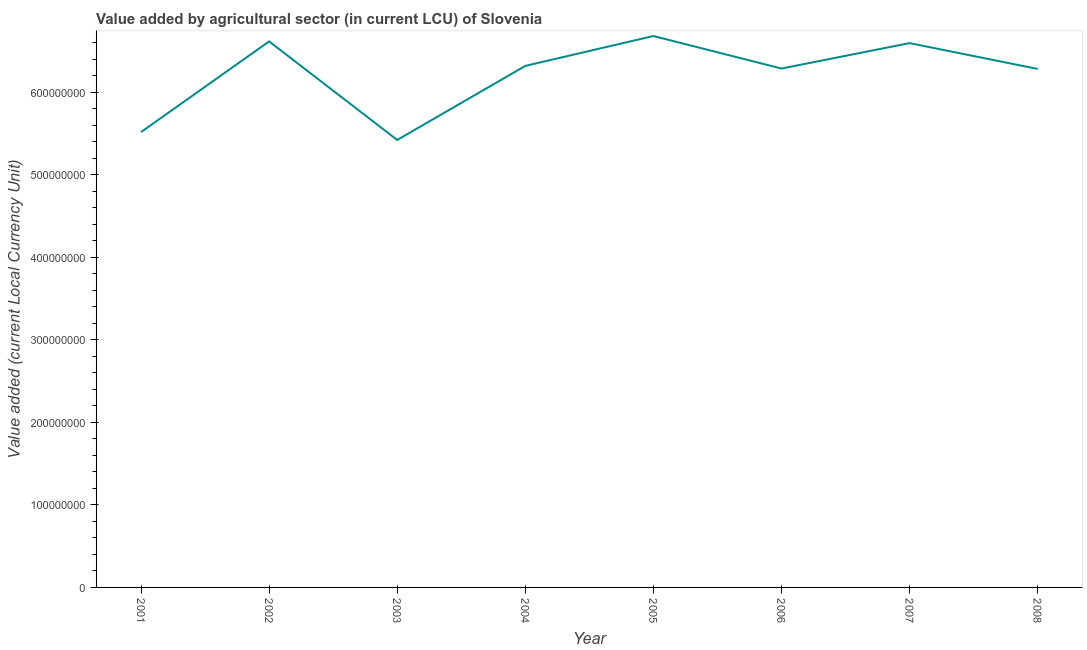What is the value added by agriculture sector in 2002?
Keep it short and to the point. 6.61e+08. Across all years, what is the maximum value added by agriculture sector?
Make the answer very short. 6.68e+08. Across all years, what is the minimum value added by agriculture sector?
Ensure brevity in your answer.  5.42e+08. In which year was the value added by agriculture sector minimum?
Your answer should be compact. 2003. What is the sum of the value added by agriculture sector?
Your answer should be compact. 4.97e+09. What is the difference between the value added by agriculture sector in 2001 and 2008?
Provide a short and direct response. -7.65e+07. What is the average value added by agriculture sector per year?
Ensure brevity in your answer.  6.21e+08. What is the median value added by agriculture sector?
Make the answer very short. 6.30e+08. In how many years, is the value added by agriculture sector greater than 520000000 LCU?
Offer a terse response. 8. Do a majority of the years between 2004 and 2005 (inclusive) have value added by agriculture sector greater than 500000000 LCU?
Keep it short and to the point. Yes. What is the ratio of the value added by agriculture sector in 2002 to that in 2007?
Provide a succinct answer. 1. Is the difference between the value added by agriculture sector in 2006 and 2008 greater than the difference between any two years?
Offer a terse response. No. What is the difference between the highest and the second highest value added by agriculture sector?
Your answer should be very brief. 6.53e+06. What is the difference between the highest and the lowest value added by agriculture sector?
Give a very brief answer. 1.26e+08. How many lines are there?
Your answer should be very brief. 1. How many years are there in the graph?
Make the answer very short. 8. What is the difference between two consecutive major ticks on the Y-axis?
Provide a succinct answer. 1.00e+08. Does the graph contain any zero values?
Your response must be concise. No. Does the graph contain grids?
Your answer should be very brief. No. What is the title of the graph?
Offer a terse response. Value added by agricultural sector (in current LCU) of Slovenia. What is the label or title of the Y-axis?
Make the answer very short. Value added (current Local Currency Unit). What is the Value added (current Local Currency Unit) of 2001?
Ensure brevity in your answer.  5.51e+08. What is the Value added (current Local Currency Unit) of 2002?
Offer a terse response. 6.61e+08. What is the Value added (current Local Currency Unit) in 2003?
Your response must be concise. 5.42e+08. What is the Value added (current Local Currency Unit) in 2004?
Offer a terse response. 6.32e+08. What is the Value added (current Local Currency Unit) in 2005?
Give a very brief answer. 6.68e+08. What is the Value added (current Local Currency Unit) in 2006?
Your response must be concise. 6.28e+08. What is the Value added (current Local Currency Unit) of 2007?
Ensure brevity in your answer.  6.59e+08. What is the Value added (current Local Currency Unit) of 2008?
Offer a terse response. 6.28e+08. What is the difference between the Value added (current Local Currency Unit) in 2001 and 2002?
Provide a succinct answer. -1.10e+08. What is the difference between the Value added (current Local Currency Unit) in 2001 and 2003?
Provide a short and direct response. 9.52e+06. What is the difference between the Value added (current Local Currency Unit) in 2001 and 2004?
Provide a short and direct response. -8.02e+07. What is the difference between the Value added (current Local Currency Unit) in 2001 and 2005?
Make the answer very short. -1.16e+08. What is the difference between the Value added (current Local Currency Unit) in 2001 and 2006?
Ensure brevity in your answer.  -7.70e+07. What is the difference between the Value added (current Local Currency Unit) in 2001 and 2007?
Keep it short and to the point. -1.08e+08. What is the difference between the Value added (current Local Currency Unit) in 2001 and 2008?
Provide a succinct answer. -7.65e+07. What is the difference between the Value added (current Local Currency Unit) in 2002 and 2003?
Your response must be concise. 1.19e+08. What is the difference between the Value added (current Local Currency Unit) in 2002 and 2004?
Give a very brief answer. 2.96e+07. What is the difference between the Value added (current Local Currency Unit) in 2002 and 2005?
Offer a terse response. -6.53e+06. What is the difference between the Value added (current Local Currency Unit) in 2002 and 2006?
Offer a terse response. 3.28e+07. What is the difference between the Value added (current Local Currency Unit) in 2002 and 2007?
Ensure brevity in your answer.  2.06e+06. What is the difference between the Value added (current Local Currency Unit) in 2002 and 2008?
Your answer should be compact. 3.34e+07. What is the difference between the Value added (current Local Currency Unit) in 2003 and 2004?
Your answer should be very brief. -8.97e+07. What is the difference between the Value added (current Local Currency Unit) in 2003 and 2005?
Your answer should be very brief. -1.26e+08. What is the difference between the Value added (current Local Currency Unit) in 2003 and 2006?
Provide a short and direct response. -8.65e+07. What is the difference between the Value added (current Local Currency Unit) in 2003 and 2007?
Your answer should be compact. -1.17e+08. What is the difference between the Value added (current Local Currency Unit) in 2003 and 2008?
Your answer should be compact. -8.60e+07. What is the difference between the Value added (current Local Currency Unit) in 2004 and 2005?
Your answer should be compact. -3.62e+07. What is the difference between the Value added (current Local Currency Unit) in 2004 and 2006?
Ensure brevity in your answer.  3.19e+06. What is the difference between the Value added (current Local Currency Unit) in 2004 and 2007?
Give a very brief answer. -2.76e+07. What is the difference between the Value added (current Local Currency Unit) in 2004 and 2008?
Keep it short and to the point. 3.70e+06. What is the difference between the Value added (current Local Currency Unit) in 2005 and 2006?
Your answer should be compact. 3.94e+07. What is the difference between the Value added (current Local Currency Unit) in 2005 and 2007?
Keep it short and to the point. 8.59e+06. What is the difference between the Value added (current Local Currency Unit) in 2005 and 2008?
Offer a terse response. 3.99e+07. What is the difference between the Value added (current Local Currency Unit) in 2006 and 2007?
Offer a terse response. -3.08e+07. What is the difference between the Value added (current Local Currency Unit) in 2006 and 2008?
Offer a very short reply. 5.10e+05. What is the difference between the Value added (current Local Currency Unit) in 2007 and 2008?
Your answer should be very brief. 3.13e+07. What is the ratio of the Value added (current Local Currency Unit) in 2001 to that in 2002?
Ensure brevity in your answer.  0.83. What is the ratio of the Value added (current Local Currency Unit) in 2001 to that in 2003?
Your answer should be compact. 1.02. What is the ratio of the Value added (current Local Currency Unit) in 2001 to that in 2004?
Make the answer very short. 0.87. What is the ratio of the Value added (current Local Currency Unit) in 2001 to that in 2005?
Your response must be concise. 0.83. What is the ratio of the Value added (current Local Currency Unit) in 2001 to that in 2006?
Offer a very short reply. 0.88. What is the ratio of the Value added (current Local Currency Unit) in 2001 to that in 2007?
Offer a terse response. 0.84. What is the ratio of the Value added (current Local Currency Unit) in 2001 to that in 2008?
Keep it short and to the point. 0.88. What is the ratio of the Value added (current Local Currency Unit) in 2002 to that in 2003?
Give a very brief answer. 1.22. What is the ratio of the Value added (current Local Currency Unit) in 2002 to that in 2004?
Keep it short and to the point. 1.05. What is the ratio of the Value added (current Local Currency Unit) in 2002 to that in 2005?
Ensure brevity in your answer.  0.99. What is the ratio of the Value added (current Local Currency Unit) in 2002 to that in 2006?
Your answer should be very brief. 1.05. What is the ratio of the Value added (current Local Currency Unit) in 2002 to that in 2008?
Offer a very short reply. 1.05. What is the ratio of the Value added (current Local Currency Unit) in 2003 to that in 2004?
Provide a succinct answer. 0.86. What is the ratio of the Value added (current Local Currency Unit) in 2003 to that in 2005?
Keep it short and to the point. 0.81. What is the ratio of the Value added (current Local Currency Unit) in 2003 to that in 2006?
Provide a succinct answer. 0.86. What is the ratio of the Value added (current Local Currency Unit) in 2003 to that in 2007?
Provide a succinct answer. 0.82. What is the ratio of the Value added (current Local Currency Unit) in 2003 to that in 2008?
Offer a very short reply. 0.86. What is the ratio of the Value added (current Local Currency Unit) in 2004 to that in 2005?
Give a very brief answer. 0.95. What is the ratio of the Value added (current Local Currency Unit) in 2004 to that in 2006?
Provide a short and direct response. 1. What is the ratio of the Value added (current Local Currency Unit) in 2004 to that in 2007?
Provide a short and direct response. 0.96. What is the ratio of the Value added (current Local Currency Unit) in 2004 to that in 2008?
Give a very brief answer. 1.01. What is the ratio of the Value added (current Local Currency Unit) in 2005 to that in 2006?
Your answer should be compact. 1.06. What is the ratio of the Value added (current Local Currency Unit) in 2005 to that in 2007?
Your response must be concise. 1.01. What is the ratio of the Value added (current Local Currency Unit) in 2005 to that in 2008?
Provide a short and direct response. 1.06. What is the ratio of the Value added (current Local Currency Unit) in 2006 to that in 2007?
Provide a short and direct response. 0.95. What is the ratio of the Value added (current Local Currency Unit) in 2007 to that in 2008?
Keep it short and to the point. 1.05. 